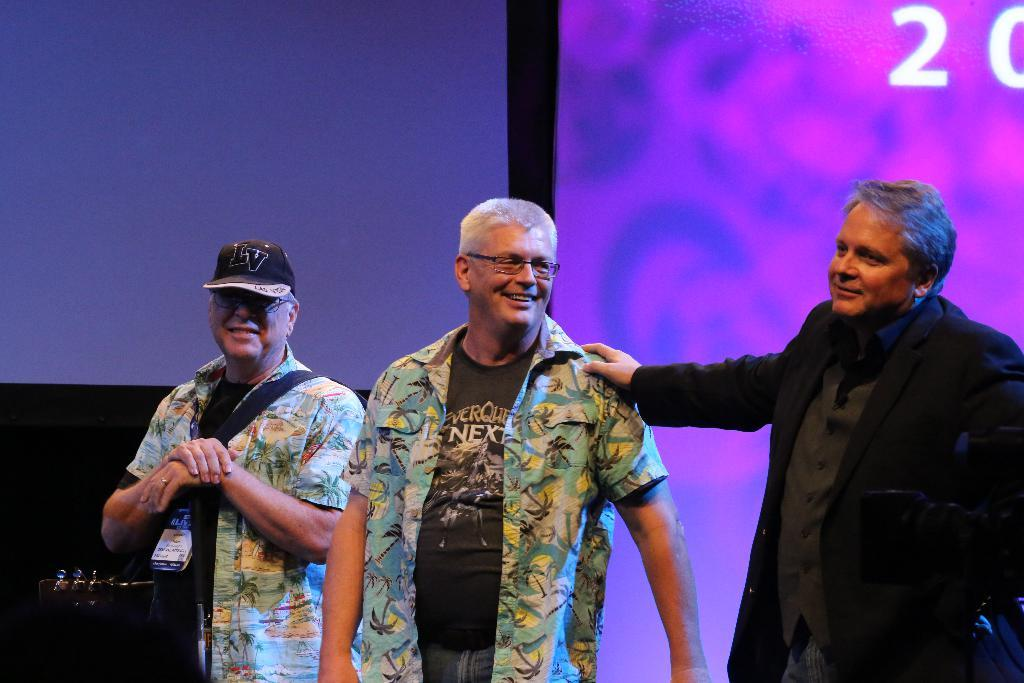How many people are present in the image? There are three people standing in the image. Can you describe the clothing or accessories of one of the people? One person is wearing a cap. What is one person doing in the image? One person is holding a musical instrument. What can be seen behind the people in the image? There appears to be a screen behind the people. What type of tin can be seen floating on the waves in the image? There is no tin or waves present in the image; it features three people and a screen in the background. 